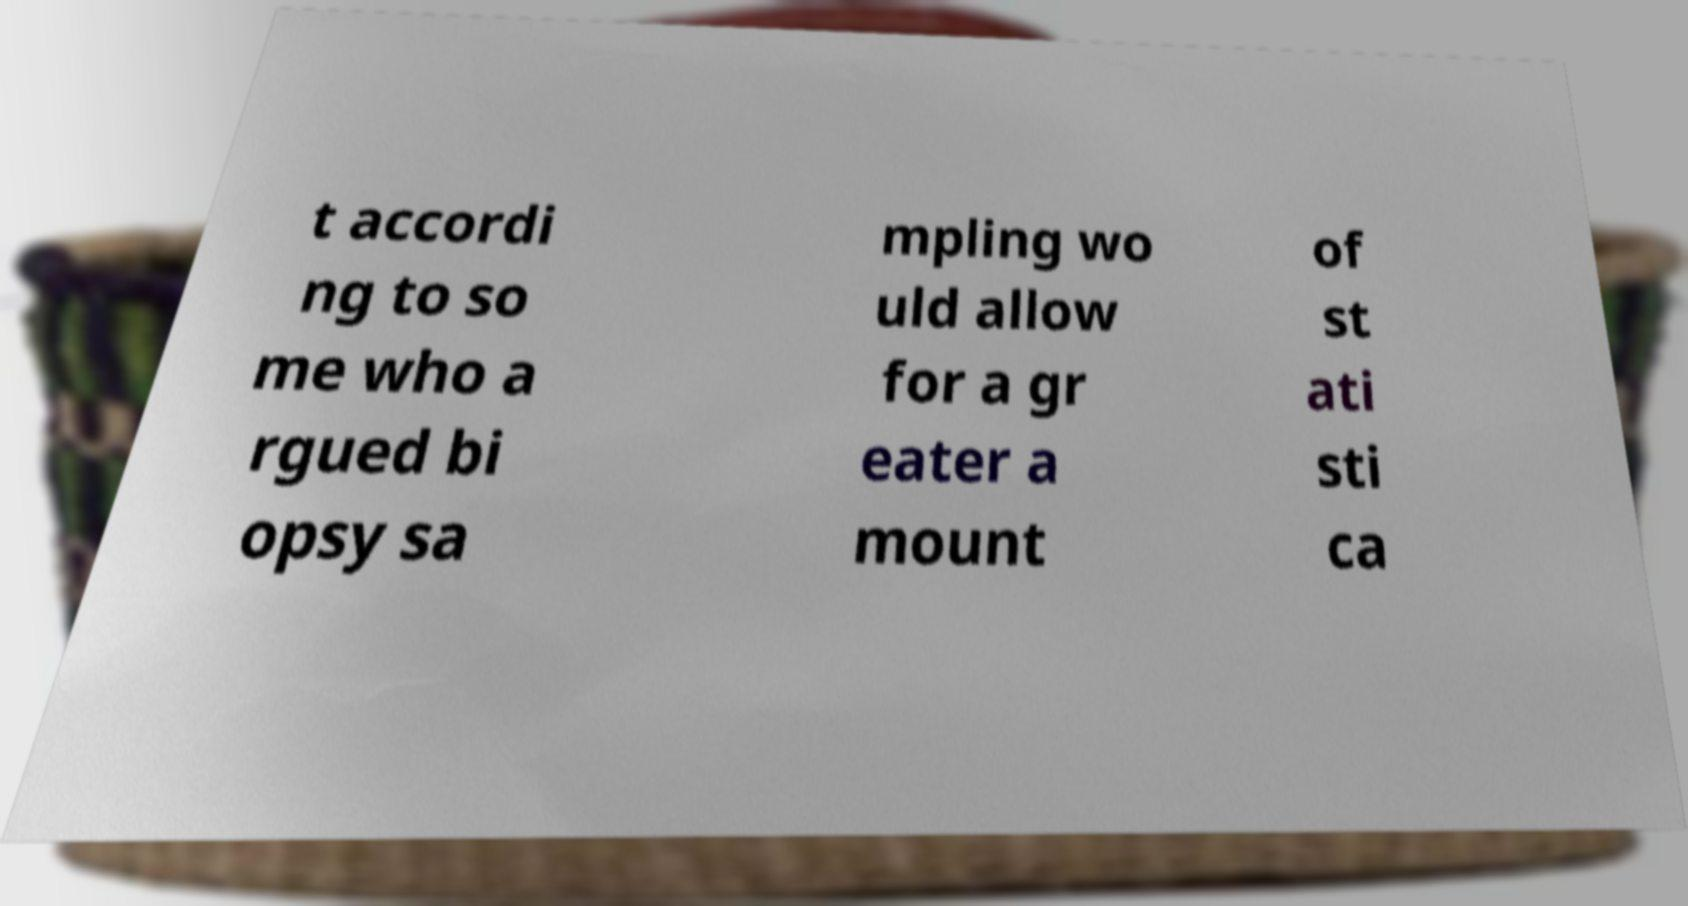There's text embedded in this image that I need extracted. Can you transcribe it verbatim? t accordi ng to so me who a rgued bi opsy sa mpling wo uld allow for a gr eater a mount of st ati sti ca 